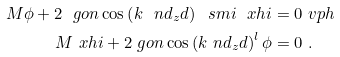<formula> <loc_0><loc_0><loc_500><loc_500>M \phi + 2 \ g o n \cos \left ( k \ n d _ { z } d \right ) \ s m i \ x h i & = 0 \ v p h \\ M \ x h i + 2 \ g o n \cos \left ( k \ n d _ { z } d \right ) ^ { l } \phi & = 0 \ .</formula> 